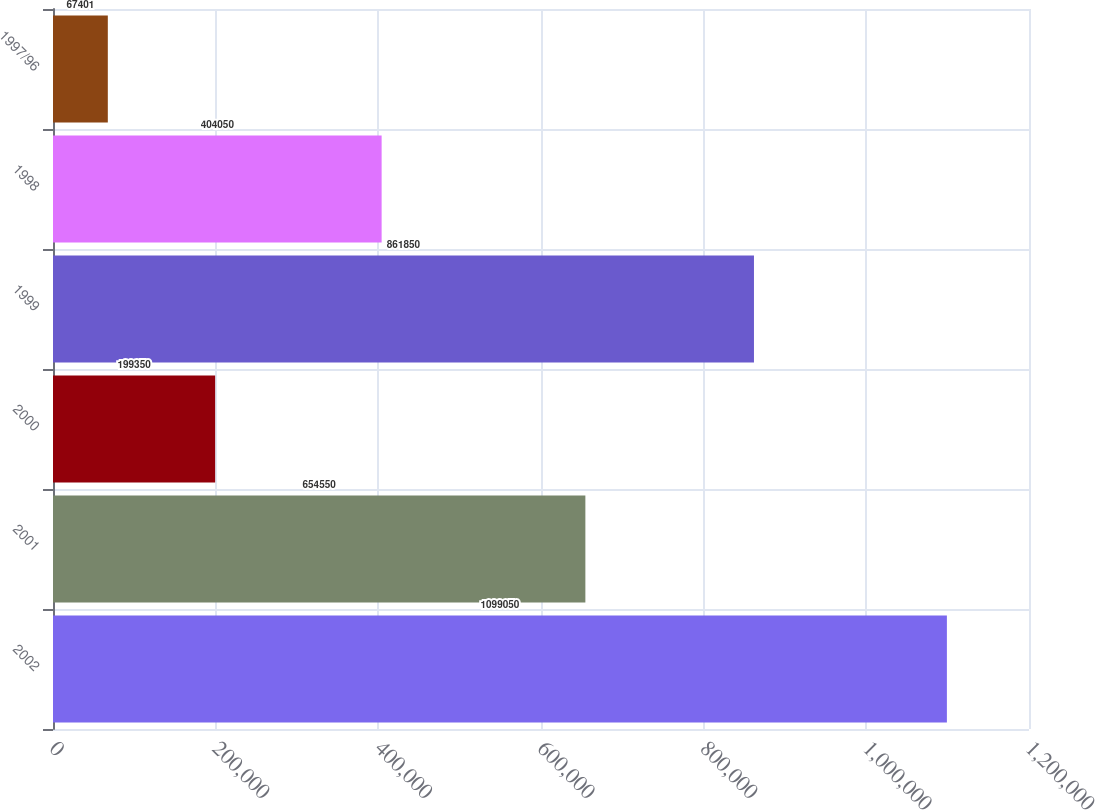Convert chart. <chart><loc_0><loc_0><loc_500><loc_500><bar_chart><fcel>2002<fcel>2001<fcel>2000<fcel>1999<fcel>1998<fcel>1997/96<nl><fcel>1.09905e+06<fcel>654550<fcel>199350<fcel>861850<fcel>404050<fcel>67401<nl></chart> 